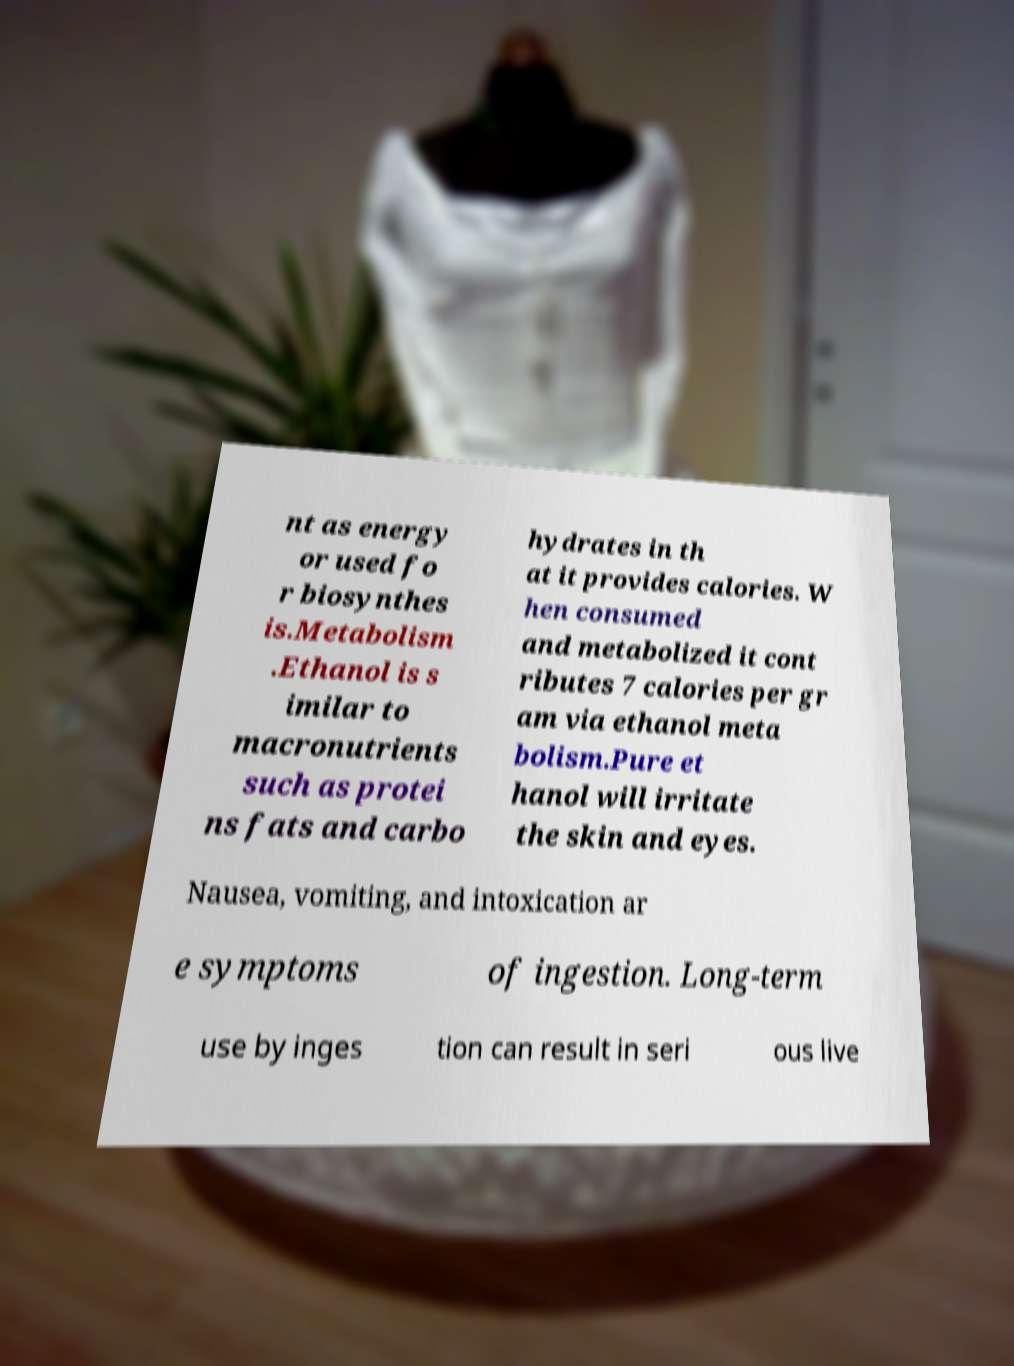Can you accurately transcribe the text from the provided image for me? nt as energy or used fo r biosynthes is.Metabolism .Ethanol is s imilar to macronutrients such as protei ns fats and carbo hydrates in th at it provides calories. W hen consumed and metabolized it cont ributes 7 calories per gr am via ethanol meta bolism.Pure et hanol will irritate the skin and eyes. Nausea, vomiting, and intoxication ar e symptoms of ingestion. Long-term use by inges tion can result in seri ous live 